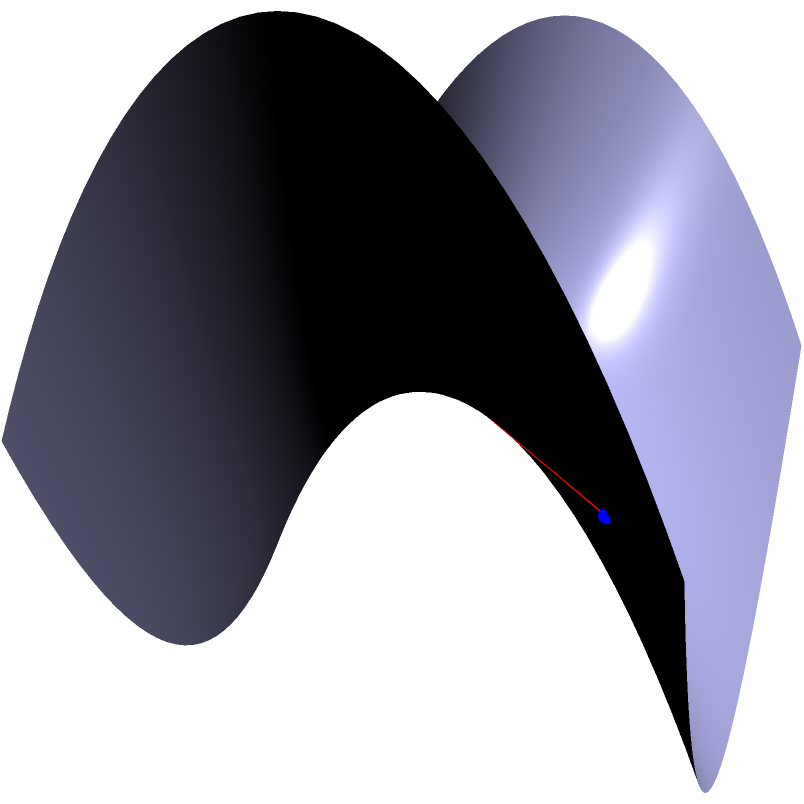As a Foreign Service Officer concerned about your relative's work in a dangerous field, you're studying various mathematical concepts that might be relevant to their safety. Consider a saddle-shaped surface represented by the function $z = x^2 - y^2$. Two points, A and B, are located at (-1.5, -1.5, 2.25) and (1.5, 1.5, 2.25) respectively. Is the straight line connecting these points the shortest path (geodesic) between them on this surface? If not, describe the shape of the actual geodesic. To determine if the straight line is the shortest path (geodesic) between points A and B on the saddle-shaped surface, we need to consider the following:

1. The surface is described by the function $z = x^2 - y^2$, which is a hyperbolic paraboloid (saddle shape).

2. In Euclidean space, the shortest path between two points is always a straight line. However, on curved surfaces, this is not always the case.

3. For a hyperbolic paraboloid, the geodesics are generally not straight lines, except in special cases:
   a) When the line is parallel to the x-axis or y-axis
   b) When the line passes through the origin (0, 0, 0)

4. In this case, the straight line from A (-1.5, -1.5, 2.25) to B (1.5, 1.5, 2.25) does not meet either of these conditions:
   a) It is diagonal, not parallel to x or y axis
   b) It does not pass through the origin (0, 0, 0)

5. The actual geodesic on this surface would curve away from the straight line, following the contours of the saddle shape.

6. The geodesic would tend to curve towards the "valley" of the saddle (where z is negative) between the two points, as this allows for a shorter path in the 3D space.

7. The exact shape of the geodesic would require solving differential equations, but qualitatively, it would form a curved path that dips below the straight line shown in the diagram.

Therefore, the straight line is not the shortest path (geodesic) between points A and B on this surface.
Answer: No, curved path dipping below the straight line 